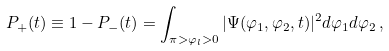<formula> <loc_0><loc_0><loc_500><loc_500>P _ { + } ( t ) \equiv 1 - P _ { - } ( t ) = \int _ { \pi > \varphi _ { l } > 0 } | \Psi ( \varphi _ { 1 } , \varphi _ { 2 } , t ) | ^ { 2 } d \varphi _ { 1 } d \varphi _ { 2 } \, ,</formula> 